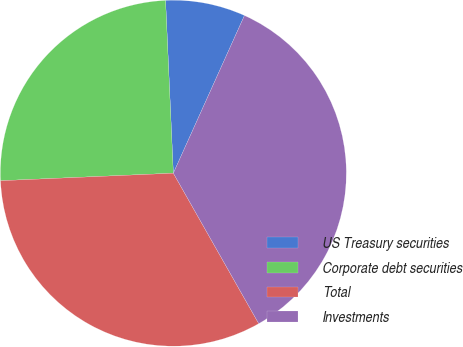Convert chart. <chart><loc_0><loc_0><loc_500><loc_500><pie_chart><fcel>US Treasury securities<fcel>Corporate debt securities<fcel>Total<fcel>Investments<nl><fcel>7.46%<fcel>24.98%<fcel>32.53%<fcel>35.04%<nl></chart> 